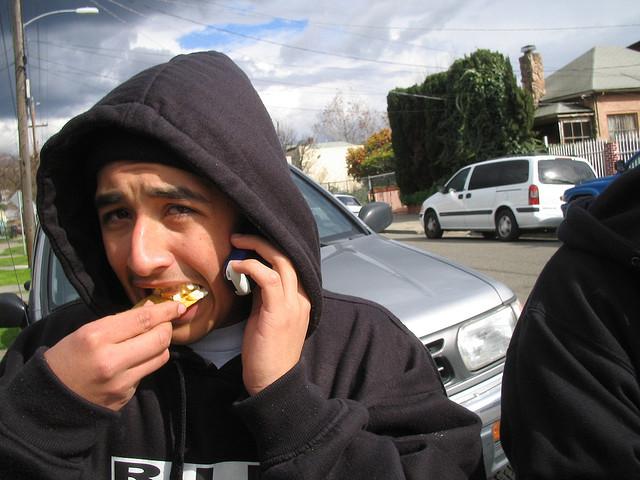Is the boy on the phone eating something?
Answer briefly. Yes. Is this man wearing a hoodie?
Answer briefly. Yes. Are these people driving?
Concise answer only. No. 